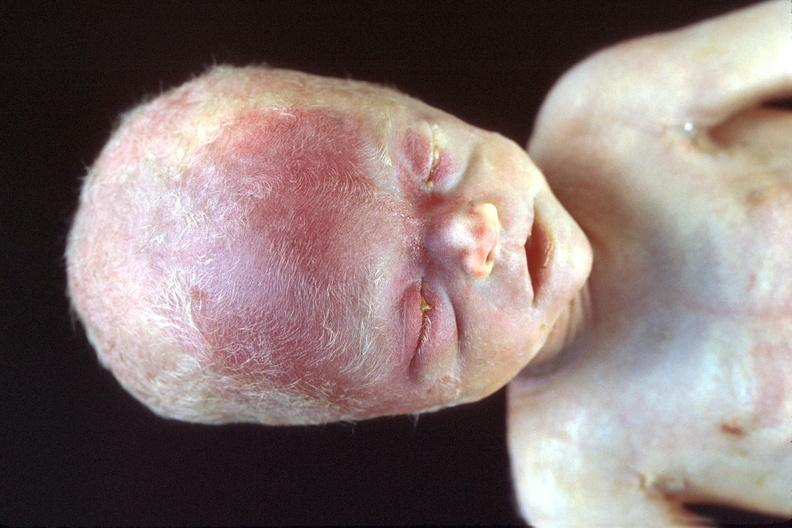what does this image show?
Answer the question using a single word or phrase. Hyaline membrane disease 